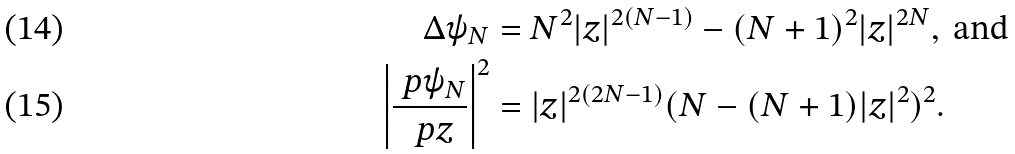Convert formula to latex. <formula><loc_0><loc_0><loc_500><loc_500>\Delta \psi _ { N } & = N ^ { 2 } | z | ^ { 2 ( N - 1 ) } - ( N + 1 ) ^ { 2 } | z | ^ { 2 N } , \text { and} \\ \left | \frac { \ p \psi _ { N } } { \ p z } \right | ^ { 2 } & = | z | ^ { 2 ( 2 N - 1 ) } ( N - ( N + 1 ) | z | ^ { 2 } ) ^ { 2 } .</formula> 